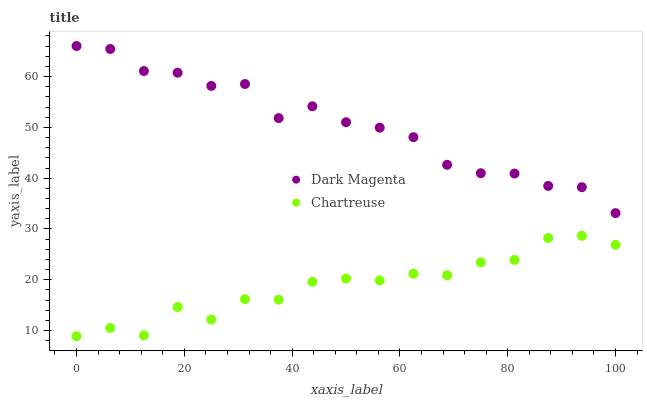Does Chartreuse have the minimum area under the curve?
Answer yes or no. Yes. Does Dark Magenta have the maximum area under the curve?
Answer yes or no. Yes. Does Dark Magenta have the minimum area under the curve?
Answer yes or no. No. Is Chartreuse the smoothest?
Answer yes or no. Yes. Is Dark Magenta the roughest?
Answer yes or no. Yes. Is Dark Magenta the smoothest?
Answer yes or no. No. Does Chartreuse have the lowest value?
Answer yes or no. Yes. Does Dark Magenta have the lowest value?
Answer yes or no. No. Does Dark Magenta have the highest value?
Answer yes or no. Yes. Is Chartreuse less than Dark Magenta?
Answer yes or no. Yes. Is Dark Magenta greater than Chartreuse?
Answer yes or no. Yes. Does Chartreuse intersect Dark Magenta?
Answer yes or no. No. 